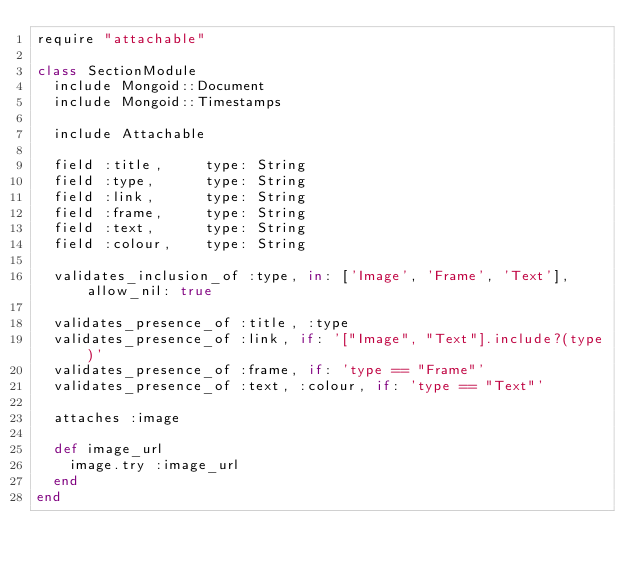Convert code to text. <code><loc_0><loc_0><loc_500><loc_500><_Ruby_>require "attachable"

class SectionModule
  include Mongoid::Document
  include Mongoid::Timestamps
  
  include Attachable

  field :title,     type: String
  field :type,      type: String
  field :link,      type: String
  field :frame,     type: String
  field :text,      type: String
  field :colour,    type: String
  
  validates_inclusion_of :type, in: ['Image', 'Frame', 'Text'], allow_nil: true
  
  validates_presence_of :title, :type
  validates_presence_of :link, if: '["Image", "Text"].include?(type)'
  validates_presence_of :frame, if: 'type == "Frame"'
  validates_presence_of :text, :colour, if: 'type == "Text"'
  
  attaches :image
  
  def image_url
    image.try :image_url
  end
end
</code> 